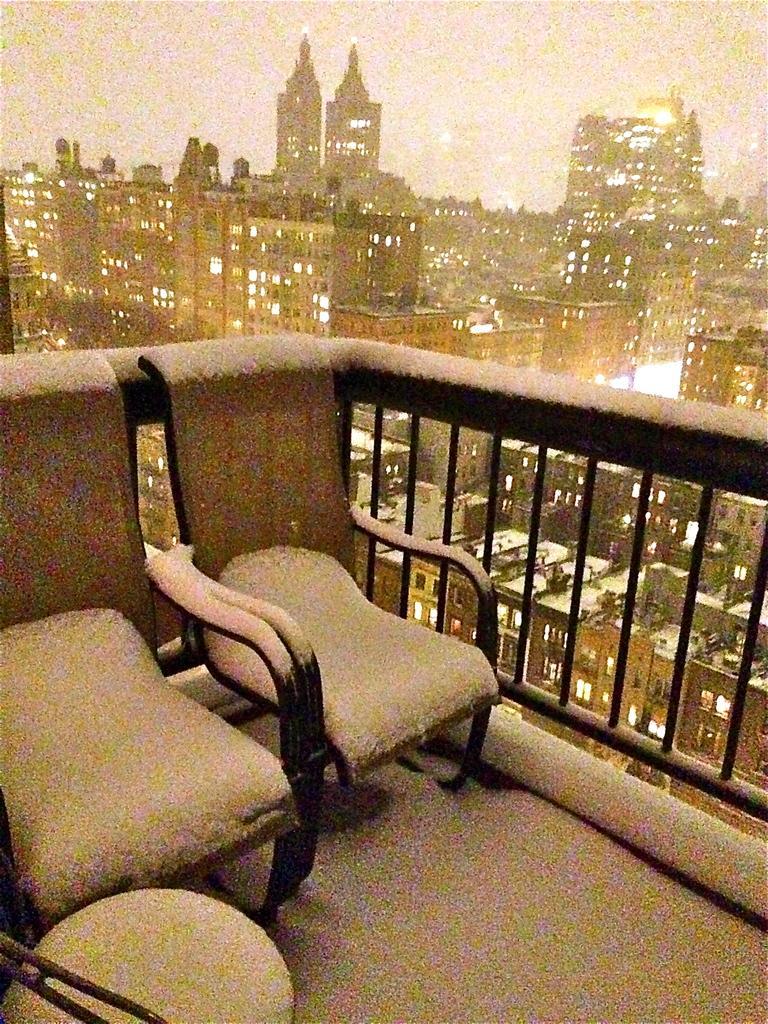Please provide a concise description of this image. In the image I can see balcony in which there two sofas and also I can see the view of a place where we have some buildings, houses. 